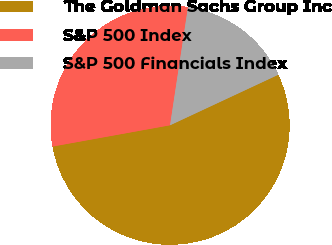<chart> <loc_0><loc_0><loc_500><loc_500><pie_chart><fcel>The Goldman Sachs Group Inc<fcel>S&P 500 Index<fcel>S&P 500 Financials Index<nl><fcel>54.1%<fcel>30.25%<fcel>15.65%<nl></chart> 